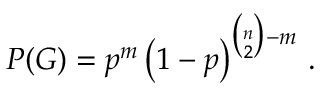Convert formula to latex. <formula><loc_0><loc_0><loc_500><loc_500>P ( G ) = p ^ { m } \left ( 1 - p \right ) ^ { { \binom { n } { 2 } } - m } \, .</formula> 